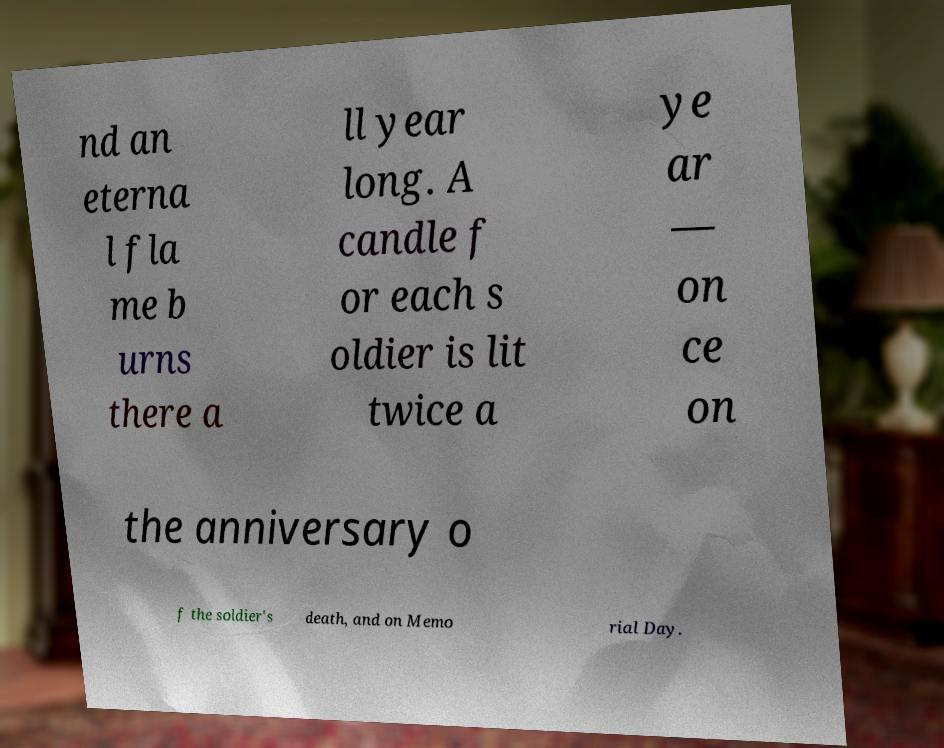Could you extract and type out the text from this image? nd an eterna l fla me b urns there a ll year long. A candle f or each s oldier is lit twice a ye ar — on ce on the anniversary o f the soldier's death, and on Memo rial Day. 